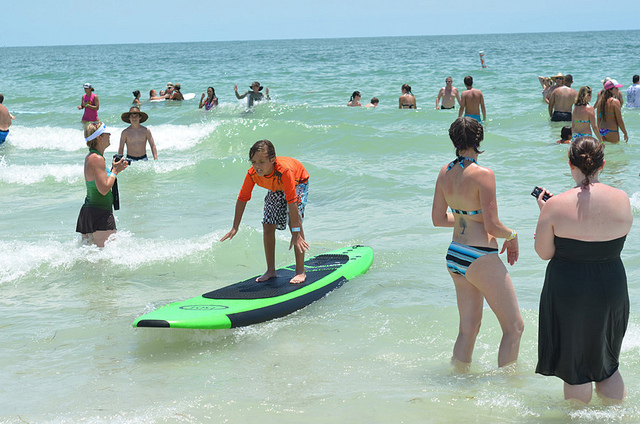Which woman has worn a black dress? The woman on the right is wearing a black dress. 